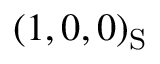Convert formula to latex. <formula><loc_0><loc_0><loc_500><loc_500>( 1 , 0 , 0 ) _ { S }</formula> 